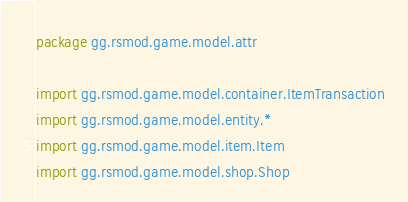Convert code to text. <code><loc_0><loc_0><loc_500><loc_500><_Kotlin_>package gg.rsmod.game.model.attr

import gg.rsmod.game.model.container.ItemTransaction
import gg.rsmod.game.model.entity.*
import gg.rsmod.game.model.item.Item
import gg.rsmod.game.model.shop.Shop</code> 